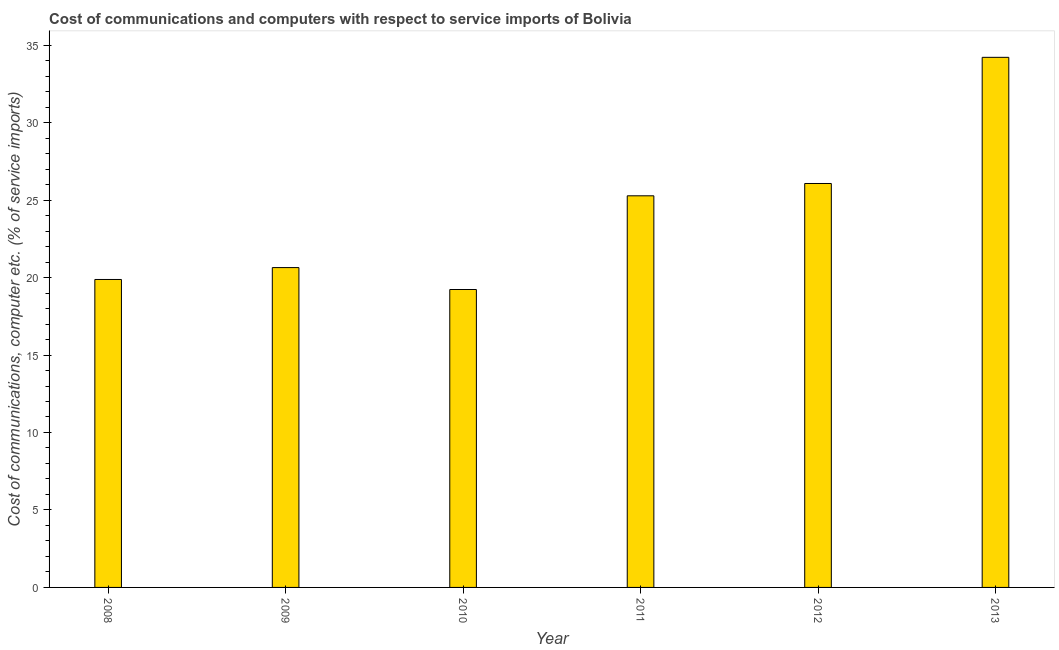Does the graph contain any zero values?
Your response must be concise. No. What is the title of the graph?
Offer a terse response. Cost of communications and computers with respect to service imports of Bolivia. What is the label or title of the X-axis?
Your answer should be very brief. Year. What is the label or title of the Y-axis?
Keep it short and to the point. Cost of communications, computer etc. (% of service imports). What is the cost of communications and computer in 2010?
Ensure brevity in your answer.  19.23. Across all years, what is the maximum cost of communications and computer?
Offer a very short reply. 34.21. Across all years, what is the minimum cost of communications and computer?
Give a very brief answer. 19.23. In which year was the cost of communications and computer maximum?
Your answer should be compact. 2013. What is the sum of the cost of communications and computer?
Give a very brief answer. 145.31. What is the difference between the cost of communications and computer in 2009 and 2010?
Offer a very short reply. 1.41. What is the average cost of communications and computer per year?
Your answer should be compact. 24.22. What is the median cost of communications and computer?
Ensure brevity in your answer.  22.96. In how many years, is the cost of communications and computer greater than 31 %?
Your response must be concise. 1. Do a majority of the years between 2009 and 2013 (inclusive) have cost of communications and computer greater than 25 %?
Your answer should be compact. Yes. What is the ratio of the cost of communications and computer in 2010 to that in 2012?
Make the answer very short. 0.74. Is the cost of communications and computer in 2008 less than that in 2012?
Your answer should be very brief. Yes. What is the difference between the highest and the second highest cost of communications and computer?
Give a very brief answer. 8.14. Is the sum of the cost of communications and computer in 2008 and 2010 greater than the maximum cost of communications and computer across all years?
Your answer should be very brief. Yes. What is the difference between the highest and the lowest cost of communications and computer?
Give a very brief answer. 14.99. In how many years, is the cost of communications and computer greater than the average cost of communications and computer taken over all years?
Your answer should be very brief. 3. How many bars are there?
Keep it short and to the point. 6. Are all the bars in the graph horizontal?
Make the answer very short. No. How many years are there in the graph?
Offer a very short reply. 6. What is the difference between two consecutive major ticks on the Y-axis?
Give a very brief answer. 5. Are the values on the major ticks of Y-axis written in scientific E-notation?
Your answer should be compact. No. What is the Cost of communications, computer etc. (% of service imports) of 2008?
Make the answer very short. 19.88. What is the Cost of communications, computer etc. (% of service imports) of 2009?
Make the answer very short. 20.64. What is the Cost of communications, computer etc. (% of service imports) of 2010?
Give a very brief answer. 19.23. What is the Cost of communications, computer etc. (% of service imports) of 2011?
Your answer should be very brief. 25.28. What is the Cost of communications, computer etc. (% of service imports) in 2012?
Keep it short and to the point. 26.07. What is the Cost of communications, computer etc. (% of service imports) in 2013?
Offer a terse response. 34.21. What is the difference between the Cost of communications, computer etc. (% of service imports) in 2008 and 2009?
Your answer should be compact. -0.77. What is the difference between the Cost of communications, computer etc. (% of service imports) in 2008 and 2010?
Keep it short and to the point. 0.65. What is the difference between the Cost of communications, computer etc. (% of service imports) in 2008 and 2011?
Ensure brevity in your answer.  -5.4. What is the difference between the Cost of communications, computer etc. (% of service imports) in 2008 and 2012?
Keep it short and to the point. -6.19. What is the difference between the Cost of communications, computer etc. (% of service imports) in 2008 and 2013?
Provide a short and direct response. -14.34. What is the difference between the Cost of communications, computer etc. (% of service imports) in 2009 and 2010?
Keep it short and to the point. 1.41. What is the difference between the Cost of communications, computer etc. (% of service imports) in 2009 and 2011?
Your answer should be very brief. -4.63. What is the difference between the Cost of communications, computer etc. (% of service imports) in 2009 and 2012?
Keep it short and to the point. -5.43. What is the difference between the Cost of communications, computer etc. (% of service imports) in 2009 and 2013?
Your response must be concise. -13.57. What is the difference between the Cost of communications, computer etc. (% of service imports) in 2010 and 2011?
Your answer should be compact. -6.05. What is the difference between the Cost of communications, computer etc. (% of service imports) in 2010 and 2012?
Provide a short and direct response. -6.84. What is the difference between the Cost of communications, computer etc. (% of service imports) in 2010 and 2013?
Keep it short and to the point. -14.98. What is the difference between the Cost of communications, computer etc. (% of service imports) in 2011 and 2012?
Provide a short and direct response. -0.79. What is the difference between the Cost of communications, computer etc. (% of service imports) in 2011 and 2013?
Offer a very short reply. -8.94. What is the difference between the Cost of communications, computer etc. (% of service imports) in 2012 and 2013?
Provide a short and direct response. -8.14. What is the ratio of the Cost of communications, computer etc. (% of service imports) in 2008 to that in 2009?
Offer a terse response. 0.96. What is the ratio of the Cost of communications, computer etc. (% of service imports) in 2008 to that in 2010?
Your answer should be compact. 1.03. What is the ratio of the Cost of communications, computer etc. (% of service imports) in 2008 to that in 2011?
Ensure brevity in your answer.  0.79. What is the ratio of the Cost of communications, computer etc. (% of service imports) in 2008 to that in 2012?
Your answer should be compact. 0.76. What is the ratio of the Cost of communications, computer etc. (% of service imports) in 2008 to that in 2013?
Ensure brevity in your answer.  0.58. What is the ratio of the Cost of communications, computer etc. (% of service imports) in 2009 to that in 2010?
Your answer should be compact. 1.07. What is the ratio of the Cost of communications, computer etc. (% of service imports) in 2009 to that in 2011?
Your answer should be very brief. 0.82. What is the ratio of the Cost of communications, computer etc. (% of service imports) in 2009 to that in 2012?
Make the answer very short. 0.79. What is the ratio of the Cost of communications, computer etc. (% of service imports) in 2009 to that in 2013?
Offer a very short reply. 0.6. What is the ratio of the Cost of communications, computer etc. (% of service imports) in 2010 to that in 2011?
Ensure brevity in your answer.  0.76. What is the ratio of the Cost of communications, computer etc. (% of service imports) in 2010 to that in 2012?
Make the answer very short. 0.74. What is the ratio of the Cost of communications, computer etc. (% of service imports) in 2010 to that in 2013?
Your response must be concise. 0.56. What is the ratio of the Cost of communications, computer etc. (% of service imports) in 2011 to that in 2012?
Make the answer very short. 0.97. What is the ratio of the Cost of communications, computer etc. (% of service imports) in 2011 to that in 2013?
Keep it short and to the point. 0.74. What is the ratio of the Cost of communications, computer etc. (% of service imports) in 2012 to that in 2013?
Ensure brevity in your answer.  0.76. 